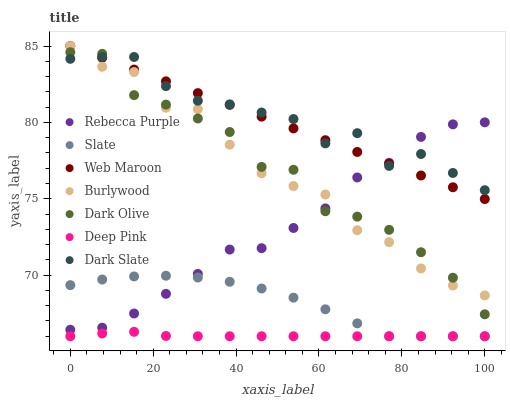Does Deep Pink have the minimum area under the curve?
Answer yes or no. Yes. Does Dark Slate have the maximum area under the curve?
Answer yes or no. Yes. Does Burlywood have the minimum area under the curve?
Answer yes or no. No. Does Burlywood have the maximum area under the curve?
Answer yes or no. No. Is Web Maroon the smoothest?
Answer yes or no. Yes. Is Dark Olive the roughest?
Answer yes or no. Yes. Is Burlywood the smoothest?
Answer yes or no. No. Is Burlywood the roughest?
Answer yes or no. No. Does Deep Pink have the lowest value?
Answer yes or no. Yes. Does Burlywood have the lowest value?
Answer yes or no. No. Does Web Maroon have the highest value?
Answer yes or no. Yes. Does Slate have the highest value?
Answer yes or no. No. Is Slate less than Burlywood?
Answer yes or no. Yes. Is Dark Olive greater than Slate?
Answer yes or no. Yes. Does Rebecca Purple intersect Dark Olive?
Answer yes or no. Yes. Is Rebecca Purple less than Dark Olive?
Answer yes or no. No. Is Rebecca Purple greater than Dark Olive?
Answer yes or no. No. Does Slate intersect Burlywood?
Answer yes or no. No. 